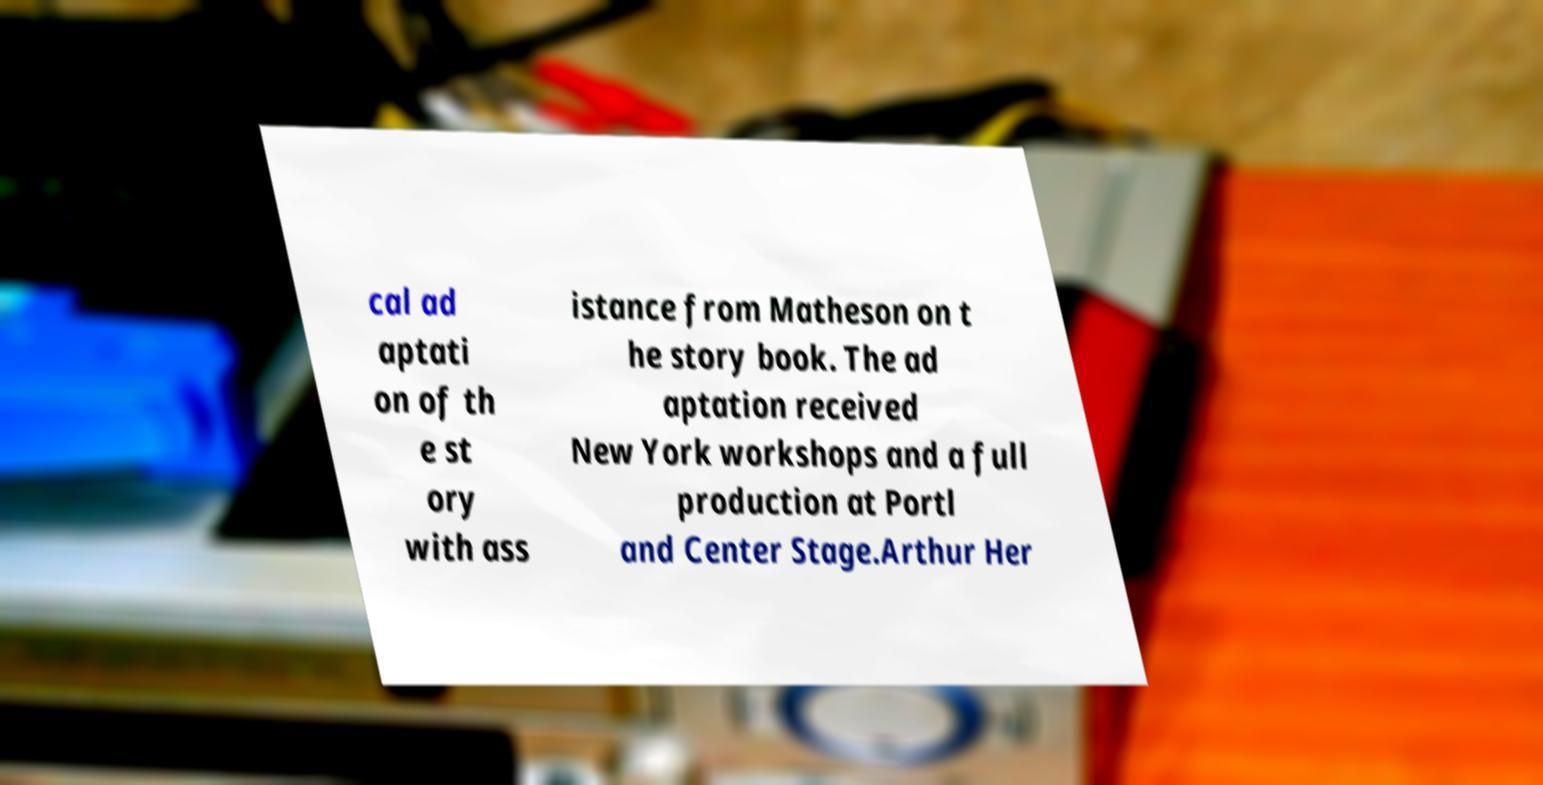Please identify and transcribe the text found in this image. cal ad aptati on of th e st ory with ass istance from Matheson on t he story book. The ad aptation received New York workshops and a full production at Portl and Center Stage.Arthur Her 